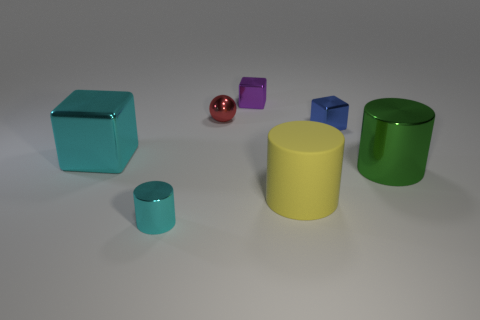Does the green thing have the same shape as the small purple object?
Provide a short and direct response. No. How big is the cyan thing on the right side of the cyan object behind the big object that is right of the yellow cylinder?
Ensure brevity in your answer.  Small. What is the big block made of?
Give a very brief answer. Metal. The metallic thing that is the same color as the small cylinder is what size?
Make the answer very short. Large. Is the shape of the blue metallic object the same as the object that is to the right of the small blue block?
Offer a terse response. No. What material is the cyan thing that is right of the cyan object that is behind the cylinder that is on the left side of the ball?
Your answer should be compact. Metal. What number of small purple balls are there?
Provide a succinct answer. 0. What number of yellow objects are matte objects or big shiny cylinders?
Make the answer very short. 1. How many other objects are there of the same shape as the red metal thing?
Ensure brevity in your answer.  0. Do the cylinder to the left of the small purple cube and the shiny block that is to the left of the small purple metal cube have the same color?
Your answer should be very brief. Yes. 